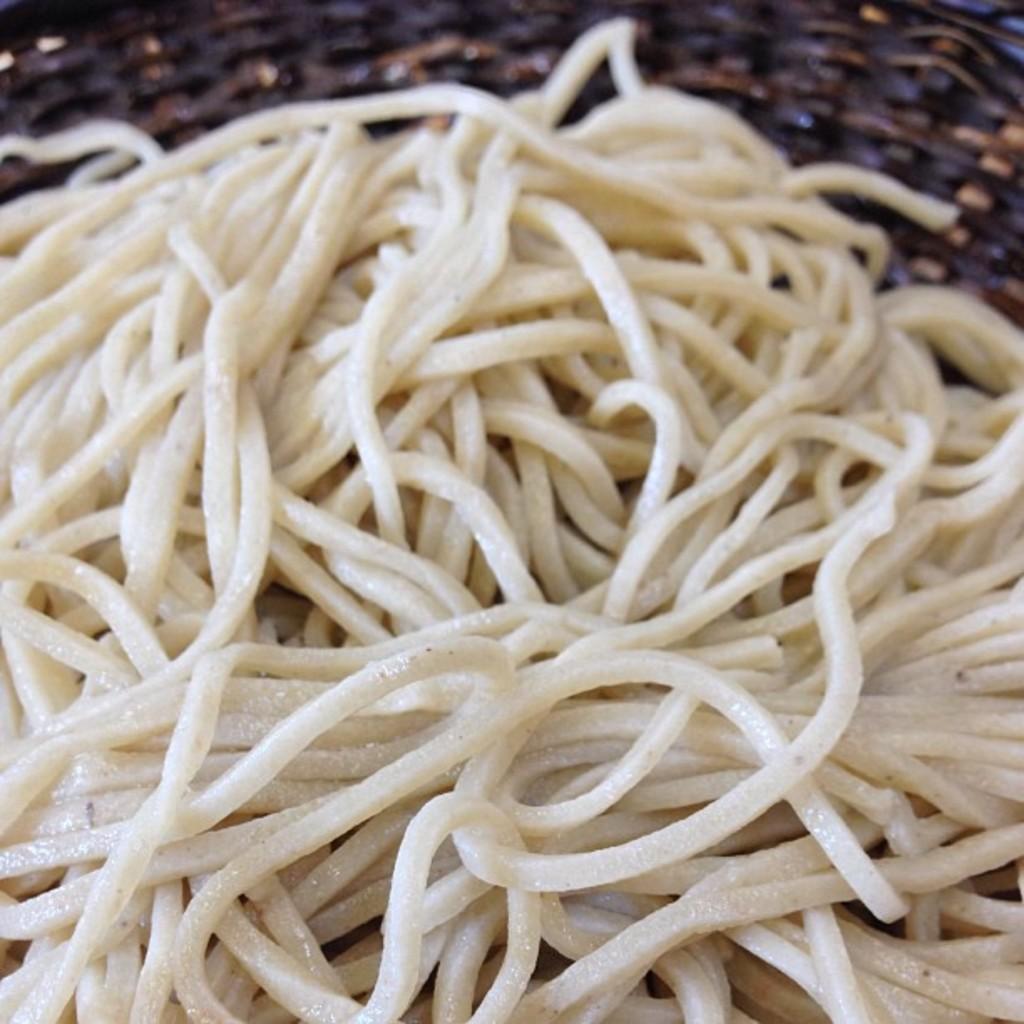Could you give a brief overview of what you see in this image? In this picture we can see noodles in the front, in the background it looks like a basket. 